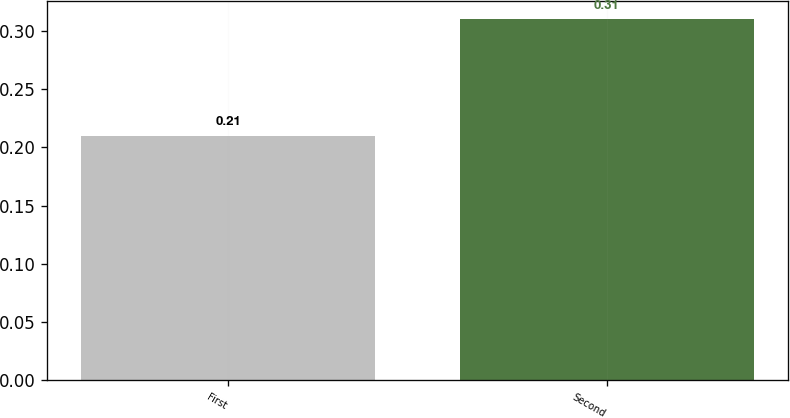Convert chart. <chart><loc_0><loc_0><loc_500><loc_500><bar_chart><fcel>First<fcel>Second<nl><fcel>0.21<fcel>0.31<nl></chart> 